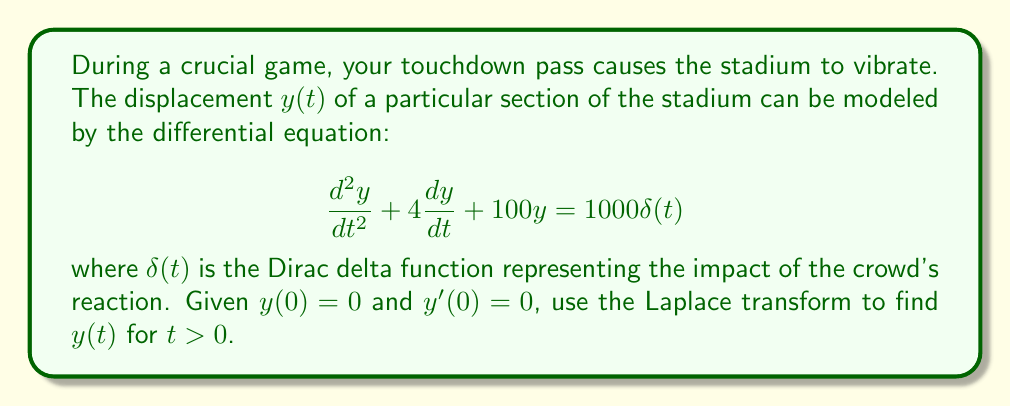Can you solve this math problem? Let's solve this step-by-step using Laplace transforms:

1) Take the Laplace transform of both sides of the equation:
   $$\mathcal{L}\{y''(t) + 4y'(t) + 100y(t)\} = \mathcal{L}\{1000\delta(t)\}$$

2) Using Laplace transform properties:
   $$[s^2Y(s) - sy(0) - y'(0)] + 4[sY(s) - y(0)] + 100Y(s) = 1000$$

3) Substitute initial conditions $y(0) = 0$ and $y'(0) = 0$:
   $$s^2Y(s) + 4sY(s) + 100Y(s) = 1000$$

4) Factor out $Y(s)$:
   $$Y(s)(s^2 + 4s + 100) = 1000$$

5) Solve for $Y(s)$:
   $$Y(s) = \frac{1000}{s^2 + 4s + 100}$$

6) Rewrite the denominator:
   $$Y(s) = \frac{1000}{(s+2)^2 + 96}$$

7) This is in the form of $\frac{A}{(s+a)^2 + b^2}$, which has the inverse Laplace transform:
   $$\mathcal{L}^{-1}\{\frac{A}{(s+a)^2 + b^2}\} = \frac{A}{b}e^{-at}\sin(bt)$$

8) In our case, $A = 1000$, $a = 2$, and $b = \sqrt{96} = 4\sqrt{6}$

9) Therefore, the inverse Laplace transform gives us:
   $$y(t) = \frac{1000}{4\sqrt{6}}e^{-2t}\sin(4\sqrt{6}t)$$

This function represents the displacement of the stadium section over time.
Answer: $$y(t) = \frac{250}{\sqrt{6}}e^{-2t}\sin(4\sqrt{6}t)$$ for $t > 0$ 